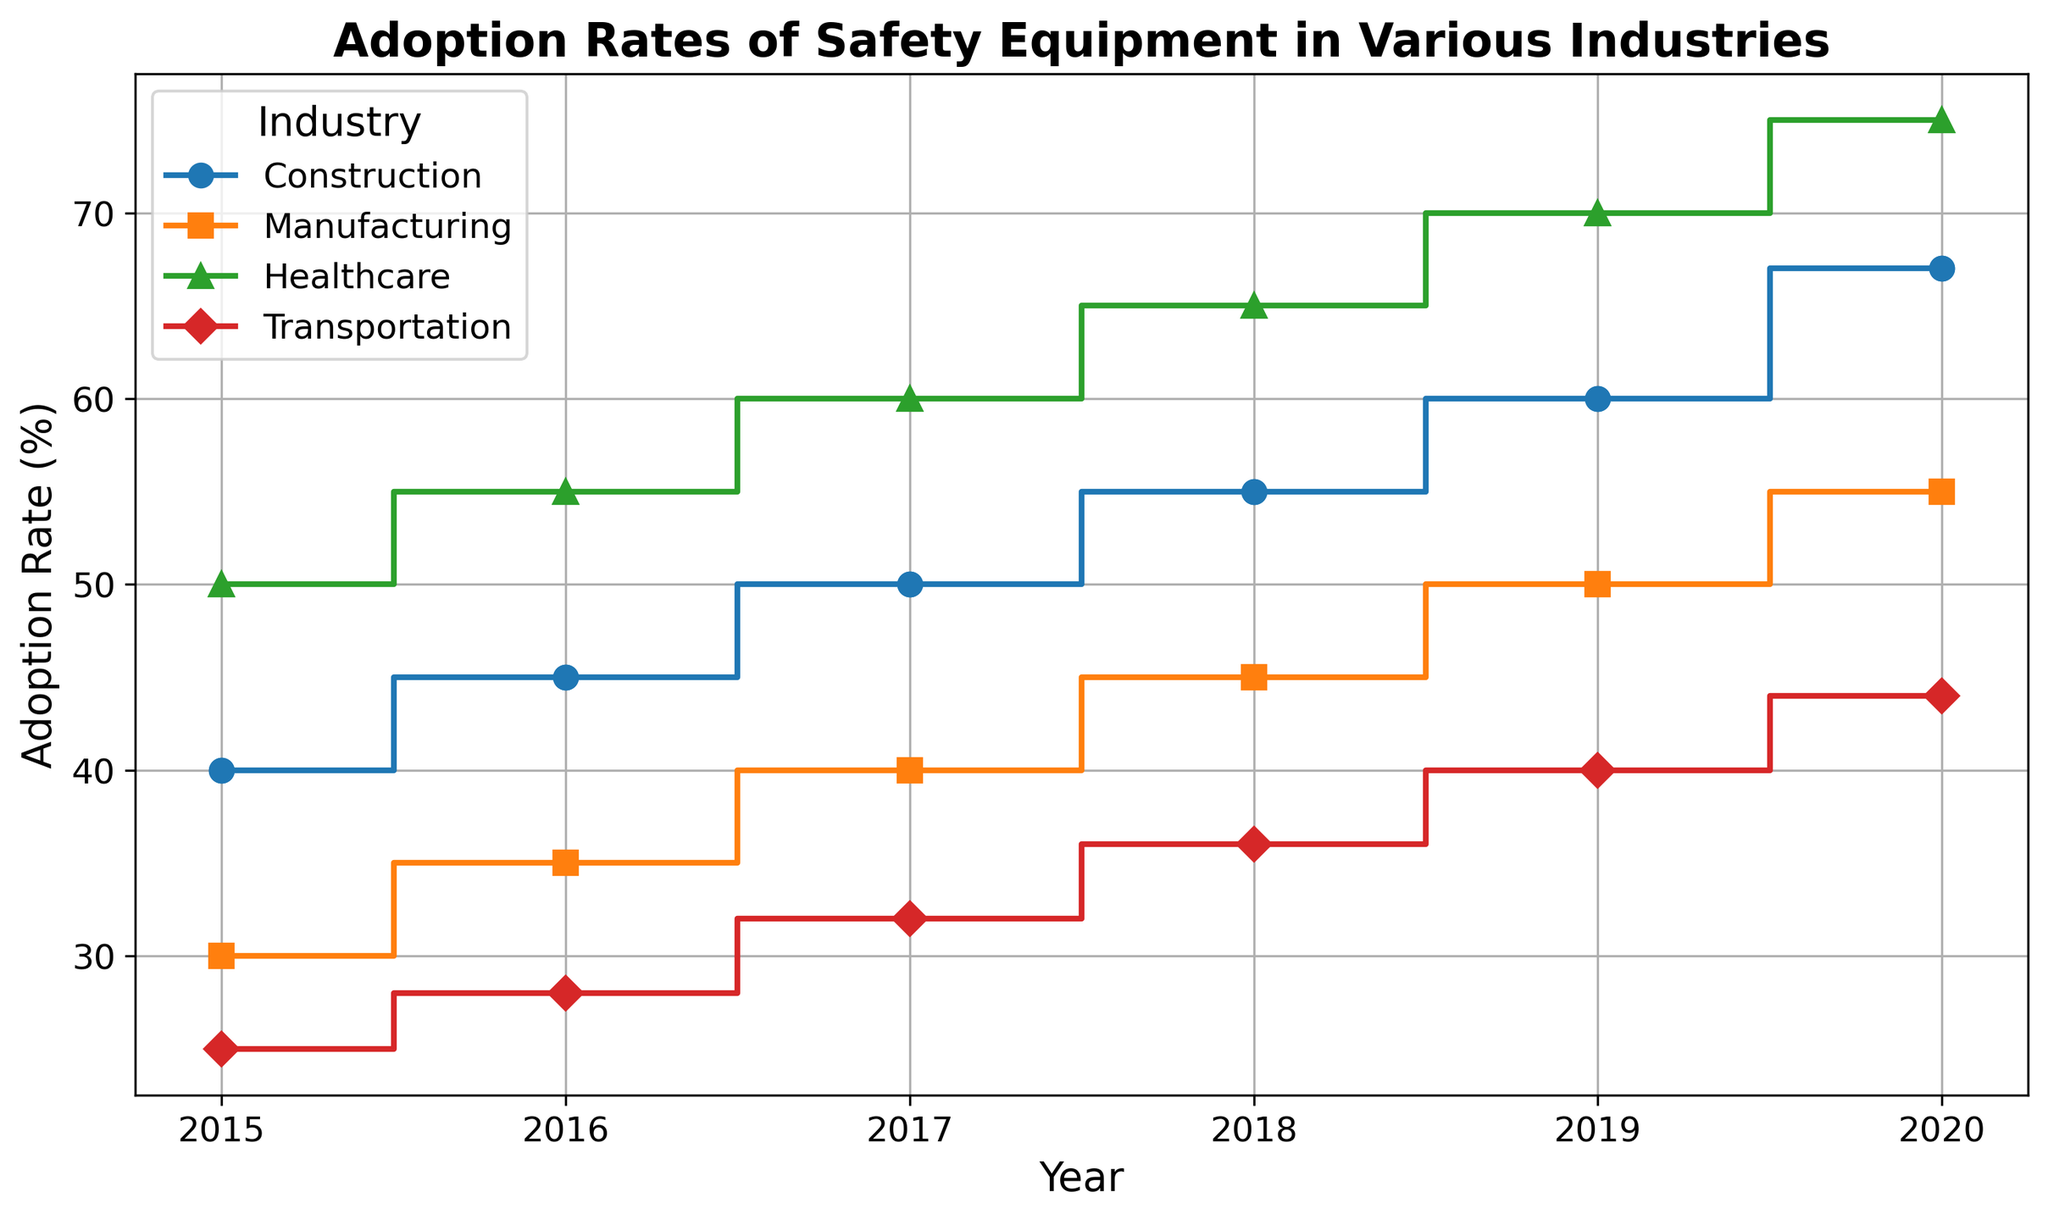Which industry had the highest adoption rate of safety equipment in 2015? Look at the starting point in 2015 for each industry. The industry's highest initial value is the one with the highest adoption rate. The healthcare industry starts with an adoption rate of 50%, which is the highest among the industries represented.
Answer: Healthcare Between the years 2017 and 2018, which industry had the highest increase in adoption rate of safety equipment? Examine the increase in adoption rate for each industry between 2017 and 2018 by subtracting the 2017 value from the 2018 value. The increases are as follows: Construction (5%), Manufacturing (5%), Healthcare (5%), and Transportation (4%). All except Transportation have a 5% increase.
Answer: Construction, Manufacturing, Healthcare What is the average adoption rate of safety equipment in the transportation industry from 2015 to 2020? Add the adoption rates for Transportation from 2015 to 2020 (25% + 28% + 32% + 36% + 40% + 44%) and divide by the number of years (6). The sum is 205%, and the average is 205 / 6 ≈ 34.2%.
Answer: 34.2% Which industry has shown a consistent increase in adoption rate of safety equipment from 2015 to 2020? Check each industry's trend line to see if it increases every year without any declines. All industries (Construction, Manufacturing, Healthcare, and Transportation) show an annual increase.
Answer: Construction, Manufacturing, Healthcare, Transportation In 2020, by how much does the adoption rate in the construction industry exceed that in the transportation industry? Look at the 2020 values for Construction (67%) and Transportation (44%), then subtract the Transportation value from the Construction value. 67% - 44% equals 23%.
Answer: 23% Which industry experienced the largest total increase in the adoption rate of safety equipment from 2015 to 2020? Calculate the total increase from 2015 to 2020 for each industry by subtracting the 2015 value from the 2020 value. The increases are: Construction (27%), Manufacturing (25%), Healthcare (25%), Transportation (19%). Construction has the largest increase.
Answer: Construction What is the overall trend in adoption rates across all industries from 2015 to 2020? Observe the general direction of the lines representing all industries. All lines trend upward, indicating an overall increase in adoption rates across all industries over time.
Answer: Increasing Which two industries had identical adoption rates in any given year? Compare the adoption rates for each industry year by year. In 2015, there are no identical rates. In subsequent years up to 2020, all rates for each industry remain unique for each year.
Answer: None In which year did the manufacturing industry reach an adoption rate of 50%? Examine the year-by-year data points for the Manufacturing industry. It hits 50% in 2019.
Answer: 2019 